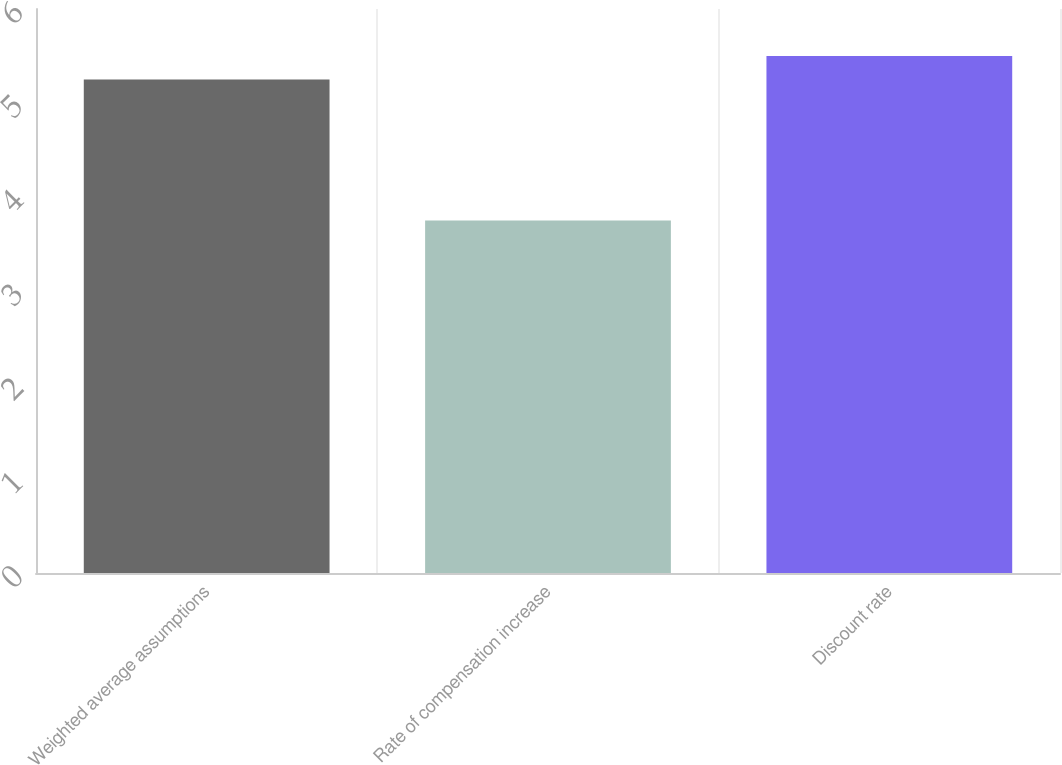Convert chart. <chart><loc_0><loc_0><loc_500><loc_500><bar_chart><fcel>Weighted average assumptions<fcel>Rate of compensation increase<fcel>Discount rate<nl><fcel>5.25<fcel>3.75<fcel>5.5<nl></chart> 